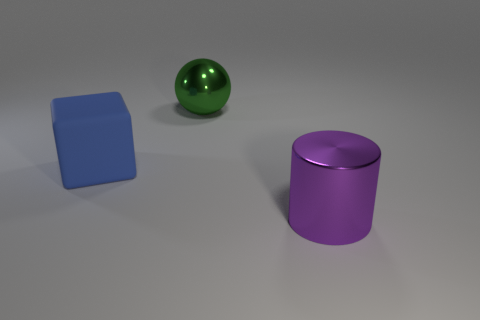Can you describe the illumination of the scene? The scene is illuminated from the top, casting soft shadows underneath the objects. The lighting appears to be homogeneous, likely provided by an overhead light source that creates a diffused effect, with longer shadows suggesting the light source isn't directly above the objects but somewhat angled. Does the lighting affect the color perception of the objects? Yes, the lighting can impact how we perceive the colors. In this image, the indirect and soft lighting maintains the true hue of the objects with minimal color distortion, which means the colors we see should be close to their actual colors under neutral lighting conditions. 